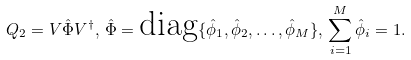Convert formula to latex. <formula><loc_0><loc_0><loc_500><loc_500>Q _ { 2 } = V \hat { \Phi } V ^ { \dag } , \, \hat { \Phi } = \text {diag} \{ \hat { \phi } _ { 1 } , \hat { \phi } _ { 2 } , \dots , \hat { \phi } _ { M } \} , \, \sum _ { i = 1 } ^ { M } \hat { \phi } _ { i } = 1 .</formula> 